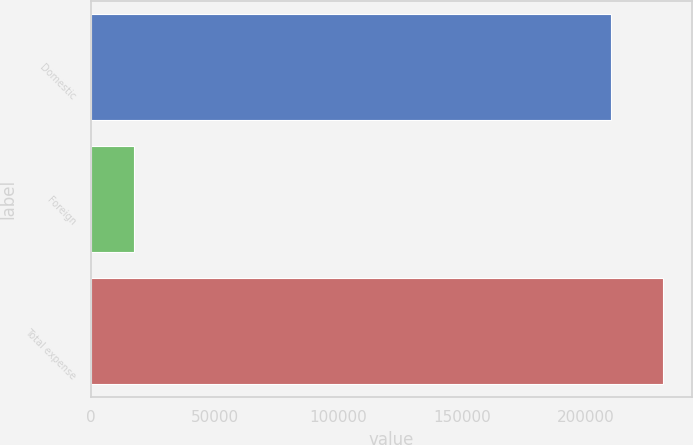Convert chart. <chart><loc_0><loc_0><loc_500><loc_500><bar_chart><fcel>Domestic<fcel>Foreign<fcel>Total expense<nl><fcel>210295<fcel>17628<fcel>231324<nl></chart> 